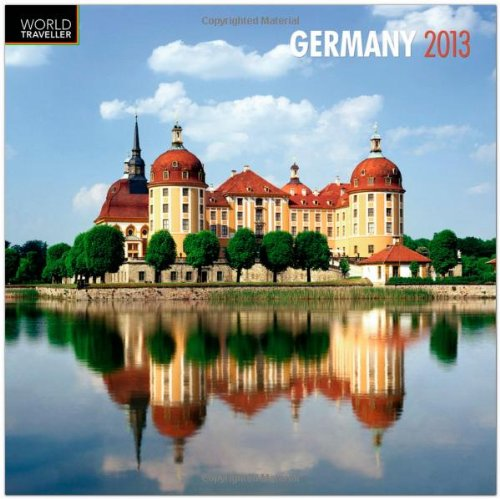Who is the author of this book?
Answer the question using a single word or phrase. BrownTrout Publishers What is the title of this book? Germany 2013 Square 12X12 Wall Calendar (Multilingual Edition) What type of book is this? Calendars Is this book related to Calendars? Yes Is this book related to Law? No Which year's calendar is this? 2013 